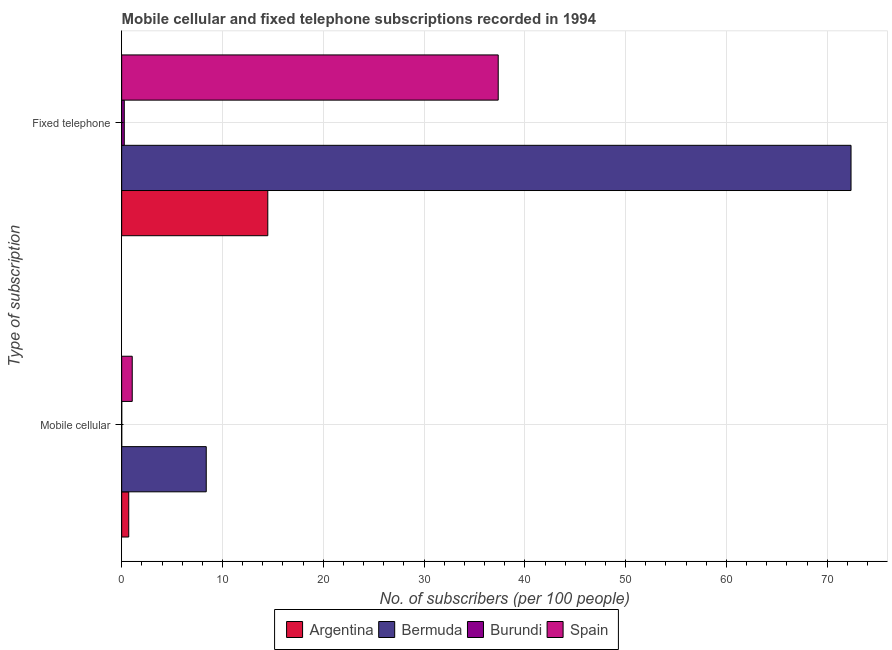How many different coloured bars are there?
Provide a short and direct response. 4. Are the number of bars on each tick of the Y-axis equal?
Offer a very short reply. Yes. How many bars are there on the 2nd tick from the top?
Your answer should be compact. 4. How many bars are there on the 1st tick from the bottom?
Provide a short and direct response. 4. What is the label of the 1st group of bars from the top?
Provide a short and direct response. Fixed telephone. What is the number of fixed telephone subscribers in Spain?
Your answer should be very brief. 37.36. Across all countries, what is the maximum number of fixed telephone subscribers?
Your answer should be compact. 72.36. Across all countries, what is the minimum number of mobile cellular subscribers?
Keep it short and to the point. 0.01. In which country was the number of fixed telephone subscribers maximum?
Keep it short and to the point. Bermuda. In which country was the number of fixed telephone subscribers minimum?
Make the answer very short. Burundi. What is the total number of fixed telephone subscribers in the graph?
Provide a succinct answer. 124.47. What is the difference between the number of mobile cellular subscribers in Burundi and that in Spain?
Your answer should be very brief. -1.04. What is the difference between the number of fixed telephone subscribers in Spain and the number of mobile cellular subscribers in Argentina?
Ensure brevity in your answer.  36.65. What is the average number of mobile cellular subscribers per country?
Offer a terse response. 2.54. What is the difference between the number of fixed telephone subscribers and number of mobile cellular subscribers in Argentina?
Provide a succinct answer. 13.8. What is the ratio of the number of fixed telephone subscribers in Spain to that in Bermuda?
Ensure brevity in your answer.  0.52. Is the number of fixed telephone subscribers in Burundi less than that in Bermuda?
Provide a succinct answer. Yes. In how many countries, is the number of mobile cellular subscribers greater than the average number of mobile cellular subscribers taken over all countries?
Keep it short and to the point. 1. What does the 3rd bar from the bottom in Fixed telephone represents?
Your answer should be very brief. Burundi. How many countries are there in the graph?
Keep it short and to the point. 4. Does the graph contain any zero values?
Your response must be concise. No. How many legend labels are there?
Offer a terse response. 4. What is the title of the graph?
Ensure brevity in your answer.  Mobile cellular and fixed telephone subscriptions recorded in 1994. What is the label or title of the X-axis?
Offer a terse response. No. of subscribers (per 100 people). What is the label or title of the Y-axis?
Ensure brevity in your answer.  Type of subscription. What is the No. of subscribers (per 100 people) of Argentina in Mobile cellular?
Provide a succinct answer. 0.7. What is the No. of subscribers (per 100 people) of Bermuda in Mobile cellular?
Your response must be concise. 8.39. What is the No. of subscribers (per 100 people) of Burundi in Mobile cellular?
Offer a very short reply. 0.01. What is the No. of subscribers (per 100 people) in Spain in Mobile cellular?
Your answer should be very brief. 1.05. What is the No. of subscribers (per 100 people) in Argentina in Fixed telephone?
Your answer should be very brief. 14.5. What is the No. of subscribers (per 100 people) in Bermuda in Fixed telephone?
Offer a very short reply. 72.36. What is the No. of subscribers (per 100 people) of Burundi in Fixed telephone?
Keep it short and to the point. 0.26. What is the No. of subscribers (per 100 people) in Spain in Fixed telephone?
Ensure brevity in your answer.  37.36. Across all Type of subscription, what is the maximum No. of subscribers (per 100 people) in Argentina?
Offer a terse response. 14.5. Across all Type of subscription, what is the maximum No. of subscribers (per 100 people) in Bermuda?
Your response must be concise. 72.36. Across all Type of subscription, what is the maximum No. of subscribers (per 100 people) of Burundi?
Your answer should be compact. 0.26. Across all Type of subscription, what is the maximum No. of subscribers (per 100 people) of Spain?
Offer a terse response. 37.36. Across all Type of subscription, what is the minimum No. of subscribers (per 100 people) in Argentina?
Provide a short and direct response. 0.7. Across all Type of subscription, what is the minimum No. of subscribers (per 100 people) in Bermuda?
Your answer should be very brief. 8.39. Across all Type of subscription, what is the minimum No. of subscribers (per 100 people) in Burundi?
Your response must be concise. 0.01. Across all Type of subscription, what is the minimum No. of subscribers (per 100 people) of Spain?
Keep it short and to the point. 1.05. What is the total No. of subscribers (per 100 people) in Argentina in the graph?
Make the answer very short. 15.2. What is the total No. of subscribers (per 100 people) in Bermuda in the graph?
Provide a short and direct response. 80.75. What is the total No. of subscribers (per 100 people) in Burundi in the graph?
Offer a terse response. 0.26. What is the total No. of subscribers (per 100 people) of Spain in the graph?
Provide a succinct answer. 38.4. What is the difference between the No. of subscribers (per 100 people) of Argentina in Mobile cellular and that in Fixed telephone?
Your response must be concise. -13.8. What is the difference between the No. of subscribers (per 100 people) of Bermuda in Mobile cellular and that in Fixed telephone?
Offer a terse response. -63.97. What is the difference between the No. of subscribers (per 100 people) of Burundi in Mobile cellular and that in Fixed telephone?
Keep it short and to the point. -0.25. What is the difference between the No. of subscribers (per 100 people) in Spain in Mobile cellular and that in Fixed telephone?
Offer a very short reply. -36.31. What is the difference between the No. of subscribers (per 100 people) in Argentina in Mobile cellular and the No. of subscribers (per 100 people) in Bermuda in Fixed telephone?
Provide a succinct answer. -71.66. What is the difference between the No. of subscribers (per 100 people) of Argentina in Mobile cellular and the No. of subscribers (per 100 people) of Burundi in Fixed telephone?
Your answer should be very brief. 0.44. What is the difference between the No. of subscribers (per 100 people) of Argentina in Mobile cellular and the No. of subscribers (per 100 people) of Spain in Fixed telephone?
Offer a terse response. -36.65. What is the difference between the No. of subscribers (per 100 people) of Bermuda in Mobile cellular and the No. of subscribers (per 100 people) of Burundi in Fixed telephone?
Offer a very short reply. 8.13. What is the difference between the No. of subscribers (per 100 people) in Bermuda in Mobile cellular and the No. of subscribers (per 100 people) in Spain in Fixed telephone?
Ensure brevity in your answer.  -28.97. What is the difference between the No. of subscribers (per 100 people) in Burundi in Mobile cellular and the No. of subscribers (per 100 people) in Spain in Fixed telephone?
Offer a terse response. -37.35. What is the average No. of subscribers (per 100 people) in Argentina per Type of subscription?
Ensure brevity in your answer.  7.6. What is the average No. of subscribers (per 100 people) in Bermuda per Type of subscription?
Offer a very short reply. 40.37. What is the average No. of subscribers (per 100 people) of Burundi per Type of subscription?
Your answer should be compact. 0.13. What is the average No. of subscribers (per 100 people) of Spain per Type of subscription?
Your answer should be compact. 19.2. What is the difference between the No. of subscribers (per 100 people) of Argentina and No. of subscribers (per 100 people) of Bermuda in Mobile cellular?
Provide a succinct answer. -7.69. What is the difference between the No. of subscribers (per 100 people) of Argentina and No. of subscribers (per 100 people) of Burundi in Mobile cellular?
Your response must be concise. 0.69. What is the difference between the No. of subscribers (per 100 people) of Argentina and No. of subscribers (per 100 people) of Spain in Mobile cellular?
Your answer should be very brief. -0.35. What is the difference between the No. of subscribers (per 100 people) in Bermuda and No. of subscribers (per 100 people) in Burundi in Mobile cellular?
Offer a terse response. 8.38. What is the difference between the No. of subscribers (per 100 people) of Bermuda and No. of subscribers (per 100 people) of Spain in Mobile cellular?
Your response must be concise. 7.34. What is the difference between the No. of subscribers (per 100 people) of Burundi and No. of subscribers (per 100 people) of Spain in Mobile cellular?
Offer a very short reply. -1.04. What is the difference between the No. of subscribers (per 100 people) in Argentina and No. of subscribers (per 100 people) in Bermuda in Fixed telephone?
Ensure brevity in your answer.  -57.86. What is the difference between the No. of subscribers (per 100 people) of Argentina and No. of subscribers (per 100 people) of Burundi in Fixed telephone?
Offer a terse response. 14.24. What is the difference between the No. of subscribers (per 100 people) in Argentina and No. of subscribers (per 100 people) in Spain in Fixed telephone?
Give a very brief answer. -22.86. What is the difference between the No. of subscribers (per 100 people) in Bermuda and No. of subscribers (per 100 people) in Burundi in Fixed telephone?
Make the answer very short. 72.1. What is the difference between the No. of subscribers (per 100 people) of Bermuda and No. of subscribers (per 100 people) of Spain in Fixed telephone?
Make the answer very short. 35. What is the difference between the No. of subscribers (per 100 people) of Burundi and No. of subscribers (per 100 people) of Spain in Fixed telephone?
Your answer should be compact. -37.1. What is the ratio of the No. of subscribers (per 100 people) in Argentina in Mobile cellular to that in Fixed telephone?
Make the answer very short. 0.05. What is the ratio of the No. of subscribers (per 100 people) of Bermuda in Mobile cellular to that in Fixed telephone?
Provide a succinct answer. 0.12. What is the ratio of the No. of subscribers (per 100 people) of Burundi in Mobile cellular to that in Fixed telephone?
Your response must be concise. 0.02. What is the ratio of the No. of subscribers (per 100 people) of Spain in Mobile cellular to that in Fixed telephone?
Make the answer very short. 0.03. What is the difference between the highest and the second highest No. of subscribers (per 100 people) of Argentina?
Offer a terse response. 13.8. What is the difference between the highest and the second highest No. of subscribers (per 100 people) in Bermuda?
Provide a short and direct response. 63.97. What is the difference between the highest and the second highest No. of subscribers (per 100 people) in Burundi?
Offer a terse response. 0.25. What is the difference between the highest and the second highest No. of subscribers (per 100 people) of Spain?
Your answer should be compact. 36.31. What is the difference between the highest and the lowest No. of subscribers (per 100 people) in Argentina?
Provide a succinct answer. 13.8. What is the difference between the highest and the lowest No. of subscribers (per 100 people) of Bermuda?
Your answer should be compact. 63.97. What is the difference between the highest and the lowest No. of subscribers (per 100 people) in Burundi?
Ensure brevity in your answer.  0.25. What is the difference between the highest and the lowest No. of subscribers (per 100 people) of Spain?
Give a very brief answer. 36.31. 